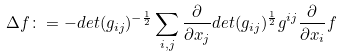Convert formula to latex. <formula><loc_0><loc_0><loc_500><loc_500>\Delta f \colon = - d e t ( g _ { i j } ) ^ { - \frac { 1 } { 2 } } \sum _ { i , j } \frac { \partial } { \partial x _ { j } } d e t ( g _ { i j } ) ^ { \frac { 1 } { 2 } } g ^ { i j } \frac { \partial } { \partial x _ { i } } f</formula> 